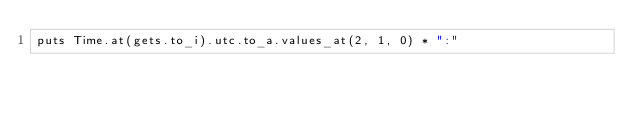Convert code to text. <code><loc_0><loc_0><loc_500><loc_500><_Ruby_>puts Time.at(gets.to_i).utc.to_a.values_at(2, 1, 0) * ":"</code> 